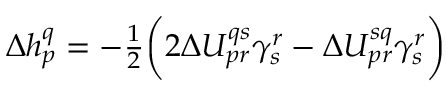Convert formula to latex. <formula><loc_0><loc_0><loc_500><loc_500>\begin{array} { r } { \Delta h _ { p } ^ { q } = - \frac { 1 } { 2 } \left ( 2 \Delta U _ { p r } ^ { q s } \gamma _ { s } ^ { r } - \Delta U _ { p r } ^ { s q } \gamma _ { s } ^ { r } \right ) } \end{array}</formula> 